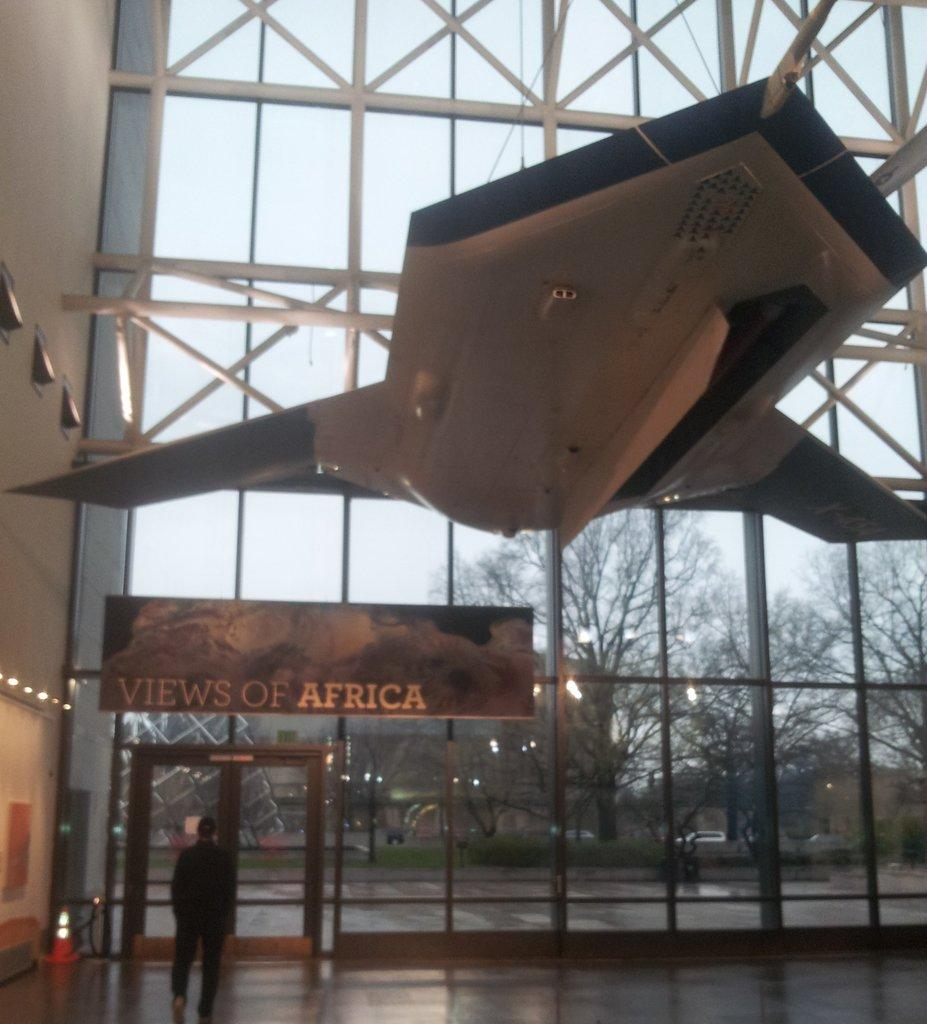<image>
Present a compact description of the photo's key features. A man standing in a large building underneath a sign with views of Africa written on it. 